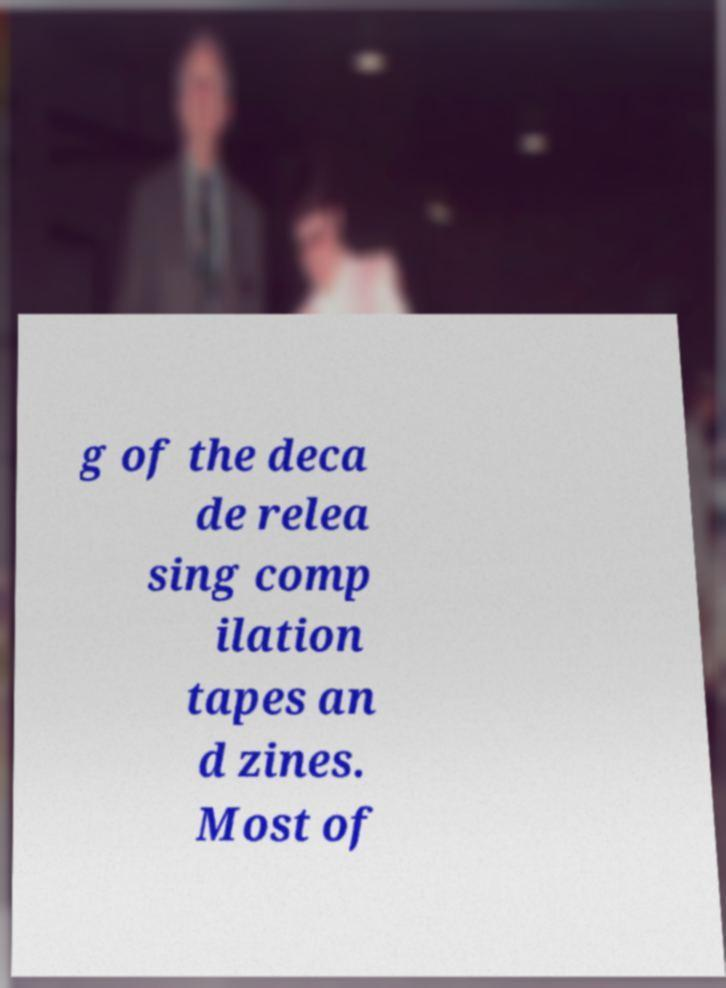I need the written content from this picture converted into text. Can you do that? g of the deca de relea sing comp ilation tapes an d zines. Most of 